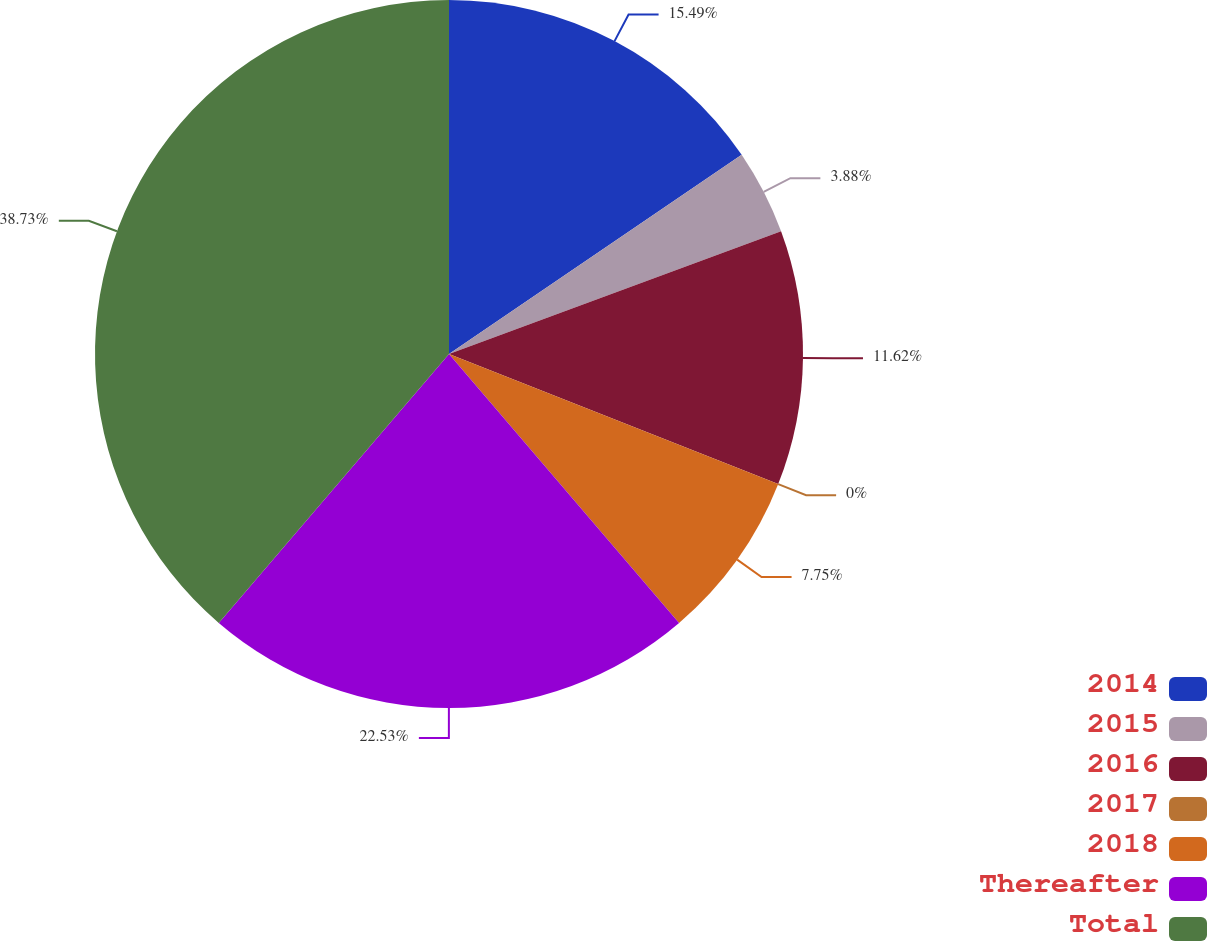<chart> <loc_0><loc_0><loc_500><loc_500><pie_chart><fcel>2014<fcel>2015<fcel>2016<fcel>2017<fcel>2018<fcel>Thereafter<fcel>Total<nl><fcel>15.49%<fcel>3.88%<fcel>11.62%<fcel>0.0%<fcel>7.75%<fcel>22.53%<fcel>38.73%<nl></chart> 